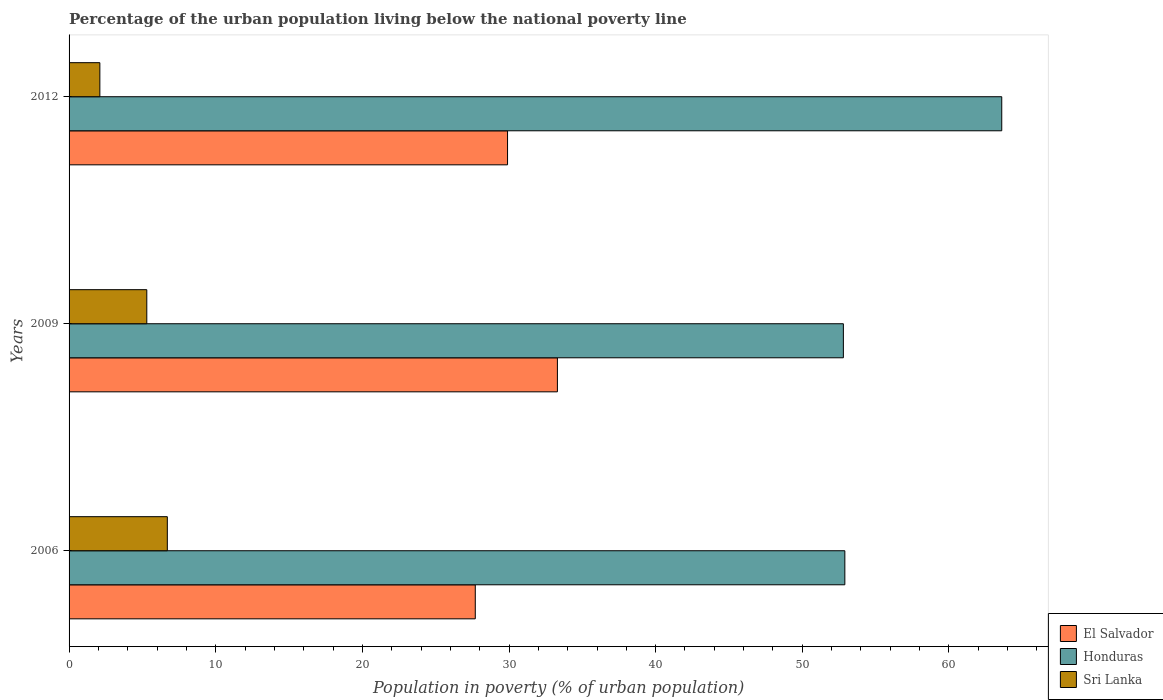How many groups of bars are there?
Provide a short and direct response. 3. Are the number of bars per tick equal to the number of legend labels?
Provide a short and direct response. Yes. How many bars are there on the 2nd tick from the top?
Offer a very short reply. 3. How many bars are there on the 1st tick from the bottom?
Your answer should be compact. 3. What is the percentage of the urban population living below the national poverty line in Sri Lanka in 2009?
Give a very brief answer. 5.3. What is the difference between the percentage of the urban population living below the national poverty line in El Salvador in 2006 and that in 2009?
Your answer should be very brief. -5.6. What is the difference between the percentage of the urban population living below the national poverty line in Honduras in 2006 and the percentage of the urban population living below the national poverty line in Sri Lanka in 2012?
Make the answer very short. 50.8. What is the average percentage of the urban population living below the national poverty line in El Salvador per year?
Provide a short and direct response. 30.3. In the year 2009, what is the difference between the percentage of the urban population living below the national poverty line in El Salvador and percentage of the urban population living below the national poverty line in Honduras?
Your answer should be very brief. -19.5. What is the ratio of the percentage of the urban population living below the national poverty line in Sri Lanka in 2006 to that in 2012?
Your response must be concise. 3.19. Is the difference between the percentage of the urban population living below the national poverty line in El Salvador in 2006 and 2012 greater than the difference between the percentage of the urban population living below the national poverty line in Honduras in 2006 and 2012?
Offer a very short reply. Yes. What is the difference between the highest and the second highest percentage of the urban population living below the national poverty line in Sri Lanka?
Provide a short and direct response. 1.4. What is the difference between the highest and the lowest percentage of the urban population living below the national poverty line in Honduras?
Make the answer very short. 10.8. In how many years, is the percentage of the urban population living below the national poverty line in El Salvador greater than the average percentage of the urban population living below the national poverty line in El Salvador taken over all years?
Ensure brevity in your answer.  1. What does the 3rd bar from the top in 2009 represents?
Ensure brevity in your answer.  El Salvador. What does the 1st bar from the bottom in 2006 represents?
Make the answer very short. El Salvador. Is it the case that in every year, the sum of the percentage of the urban population living below the national poverty line in Sri Lanka and percentage of the urban population living below the national poverty line in El Salvador is greater than the percentage of the urban population living below the national poverty line in Honduras?
Keep it short and to the point. No. How many bars are there?
Provide a short and direct response. 9. Does the graph contain any zero values?
Provide a short and direct response. No. Does the graph contain grids?
Your answer should be very brief. No. How are the legend labels stacked?
Your answer should be compact. Vertical. What is the title of the graph?
Offer a very short reply. Percentage of the urban population living below the national poverty line. Does "Eritrea" appear as one of the legend labels in the graph?
Provide a short and direct response. No. What is the label or title of the X-axis?
Provide a succinct answer. Population in poverty (% of urban population). What is the label or title of the Y-axis?
Your answer should be very brief. Years. What is the Population in poverty (% of urban population) of El Salvador in 2006?
Your response must be concise. 27.7. What is the Population in poverty (% of urban population) in Honduras in 2006?
Ensure brevity in your answer.  52.9. What is the Population in poverty (% of urban population) in Sri Lanka in 2006?
Make the answer very short. 6.7. What is the Population in poverty (% of urban population) in El Salvador in 2009?
Offer a terse response. 33.3. What is the Population in poverty (% of urban population) of Honduras in 2009?
Provide a succinct answer. 52.8. What is the Population in poverty (% of urban population) of El Salvador in 2012?
Your answer should be compact. 29.9. What is the Population in poverty (% of urban population) in Honduras in 2012?
Your answer should be compact. 63.6. Across all years, what is the maximum Population in poverty (% of urban population) in El Salvador?
Make the answer very short. 33.3. Across all years, what is the maximum Population in poverty (% of urban population) in Honduras?
Your answer should be very brief. 63.6. Across all years, what is the maximum Population in poverty (% of urban population) of Sri Lanka?
Provide a succinct answer. 6.7. Across all years, what is the minimum Population in poverty (% of urban population) of El Salvador?
Keep it short and to the point. 27.7. Across all years, what is the minimum Population in poverty (% of urban population) of Honduras?
Keep it short and to the point. 52.8. What is the total Population in poverty (% of urban population) in El Salvador in the graph?
Your answer should be very brief. 90.9. What is the total Population in poverty (% of urban population) in Honduras in the graph?
Your response must be concise. 169.3. What is the total Population in poverty (% of urban population) of Sri Lanka in the graph?
Provide a short and direct response. 14.1. What is the difference between the Population in poverty (% of urban population) of El Salvador in 2006 and that in 2009?
Offer a terse response. -5.6. What is the difference between the Population in poverty (% of urban population) of El Salvador in 2006 and that in 2012?
Keep it short and to the point. -2.2. What is the difference between the Population in poverty (% of urban population) in Honduras in 2006 and that in 2012?
Your answer should be very brief. -10.7. What is the difference between the Population in poverty (% of urban population) of Sri Lanka in 2006 and that in 2012?
Ensure brevity in your answer.  4.6. What is the difference between the Population in poverty (% of urban population) in El Salvador in 2009 and that in 2012?
Your answer should be very brief. 3.4. What is the difference between the Population in poverty (% of urban population) in El Salvador in 2006 and the Population in poverty (% of urban population) in Honduras in 2009?
Offer a very short reply. -25.1. What is the difference between the Population in poverty (% of urban population) in El Salvador in 2006 and the Population in poverty (% of urban population) in Sri Lanka in 2009?
Your answer should be very brief. 22.4. What is the difference between the Population in poverty (% of urban population) of Honduras in 2006 and the Population in poverty (% of urban population) of Sri Lanka in 2009?
Provide a succinct answer. 47.6. What is the difference between the Population in poverty (% of urban population) of El Salvador in 2006 and the Population in poverty (% of urban population) of Honduras in 2012?
Offer a terse response. -35.9. What is the difference between the Population in poverty (% of urban population) of El Salvador in 2006 and the Population in poverty (% of urban population) of Sri Lanka in 2012?
Give a very brief answer. 25.6. What is the difference between the Population in poverty (% of urban population) in Honduras in 2006 and the Population in poverty (% of urban population) in Sri Lanka in 2012?
Give a very brief answer. 50.8. What is the difference between the Population in poverty (% of urban population) of El Salvador in 2009 and the Population in poverty (% of urban population) of Honduras in 2012?
Provide a succinct answer. -30.3. What is the difference between the Population in poverty (% of urban population) of El Salvador in 2009 and the Population in poverty (% of urban population) of Sri Lanka in 2012?
Your response must be concise. 31.2. What is the difference between the Population in poverty (% of urban population) in Honduras in 2009 and the Population in poverty (% of urban population) in Sri Lanka in 2012?
Keep it short and to the point. 50.7. What is the average Population in poverty (% of urban population) in El Salvador per year?
Your answer should be compact. 30.3. What is the average Population in poverty (% of urban population) in Honduras per year?
Offer a very short reply. 56.43. What is the average Population in poverty (% of urban population) of Sri Lanka per year?
Provide a succinct answer. 4.7. In the year 2006, what is the difference between the Population in poverty (% of urban population) in El Salvador and Population in poverty (% of urban population) in Honduras?
Your answer should be very brief. -25.2. In the year 2006, what is the difference between the Population in poverty (% of urban population) in El Salvador and Population in poverty (% of urban population) in Sri Lanka?
Your answer should be compact. 21. In the year 2006, what is the difference between the Population in poverty (% of urban population) of Honduras and Population in poverty (% of urban population) of Sri Lanka?
Offer a terse response. 46.2. In the year 2009, what is the difference between the Population in poverty (% of urban population) in El Salvador and Population in poverty (% of urban population) in Honduras?
Offer a terse response. -19.5. In the year 2009, what is the difference between the Population in poverty (% of urban population) of El Salvador and Population in poverty (% of urban population) of Sri Lanka?
Make the answer very short. 28. In the year 2009, what is the difference between the Population in poverty (% of urban population) in Honduras and Population in poverty (% of urban population) in Sri Lanka?
Your response must be concise. 47.5. In the year 2012, what is the difference between the Population in poverty (% of urban population) in El Salvador and Population in poverty (% of urban population) in Honduras?
Offer a very short reply. -33.7. In the year 2012, what is the difference between the Population in poverty (% of urban population) in El Salvador and Population in poverty (% of urban population) in Sri Lanka?
Offer a very short reply. 27.8. In the year 2012, what is the difference between the Population in poverty (% of urban population) of Honduras and Population in poverty (% of urban population) of Sri Lanka?
Offer a very short reply. 61.5. What is the ratio of the Population in poverty (% of urban population) of El Salvador in 2006 to that in 2009?
Your answer should be compact. 0.83. What is the ratio of the Population in poverty (% of urban population) of Sri Lanka in 2006 to that in 2009?
Your answer should be compact. 1.26. What is the ratio of the Population in poverty (% of urban population) in El Salvador in 2006 to that in 2012?
Your response must be concise. 0.93. What is the ratio of the Population in poverty (% of urban population) in Honduras in 2006 to that in 2012?
Make the answer very short. 0.83. What is the ratio of the Population in poverty (% of urban population) in Sri Lanka in 2006 to that in 2012?
Provide a short and direct response. 3.19. What is the ratio of the Population in poverty (% of urban population) in El Salvador in 2009 to that in 2012?
Your answer should be very brief. 1.11. What is the ratio of the Population in poverty (% of urban population) in Honduras in 2009 to that in 2012?
Offer a terse response. 0.83. What is the ratio of the Population in poverty (% of urban population) of Sri Lanka in 2009 to that in 2012?
Ensure brevity in your answer.  2.52. What is the difference between the highest and the second highest Population in poverty (% of urban population) in Honduras?
Make the answer very short. 10.7. What is the difference between the highest and the lowest Population in poverty (% of urban population) in El Salvador?
Offer a terse response. 5.6. What is the difference between the highest and the lowest Population in poverty (% of urban population) in Honduras?
Ensure brevity in your answer.  10.8. 